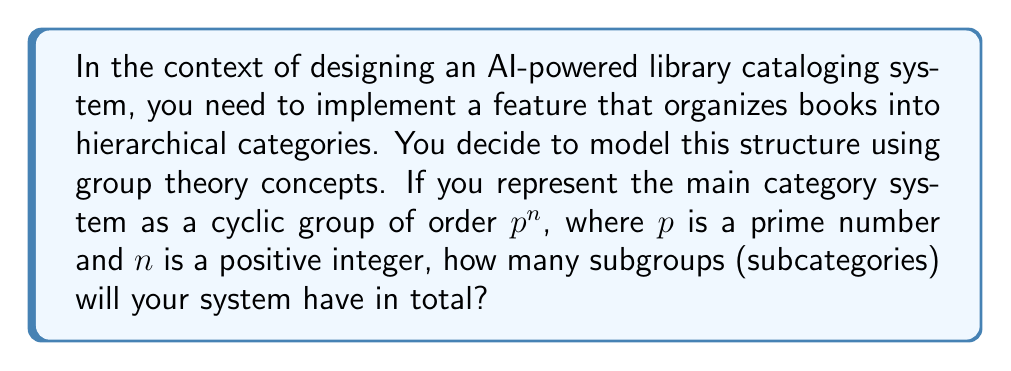Could you help me with this problem? Let's approach this step-by-step:

1) In a cyclic group of order $p^n$, where $p$ is prime and $n$ is a positive integer, the number of subgroups is equal to the number of divisors of $p^n$.

2) The divisors of $p^n$ are $1, p, p^2, ..., p^n$.

3) To count these divisors, we need to count how many choices we have for the exponent of $p$. The exponent can be any integer from 0 to $n$ (inclusive).

4) Therefore, the number of divisors (and thus subgroups) is $n+1$.

In the context of the library cataloging system:
- The main category system is represented by the entire cyclic group of order $p^n$.
- Each subgroup represents a subcategory.
- The trivial subgroup (of order 1) represents the most specific subcategory.
- The entire group represents the broadest category.
- Subgroups of orders $p, p^2, ..., p^{n-1}$ represent intermediate subcategories.

This structure allows for a flexible and hierarchical organization of books, where each book can be assigned to a category at any level of specificity.
Answer: The number of subgroups in a cyclic group of order $p^n$, where $p$ is prime and $n$ is a positive integer, is $n+1$. 